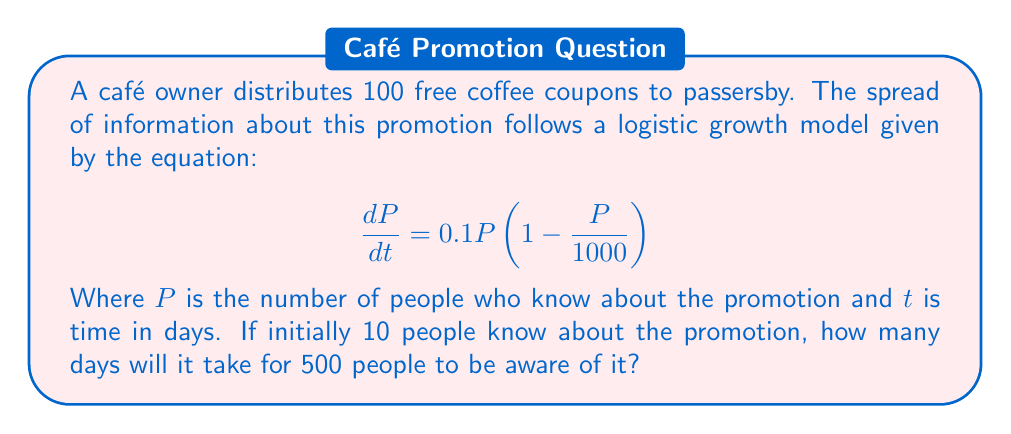Help me with this question. To solve this problem, we need to use the logistic growth model and integrate it to find the time $t$ when $P = 500$. Let's follow these steps:

1) The logistic growth model is given by:
   $$\frac{dP}{dt} = 0.1P(1 - \frac{P}{1000})$$

2) The solution to this differential equation is:
   $$P(t) = \frac{1000}{1 + (\frac{1000}{P_0} - 1)e^{-0.1t}}$$
   Where $P_0$ is the initial population.

3) We're given that $P_0 = 10$ and we want to find $t$ when $P = 500$. Let's substitute these values:
   $$500 = \frac{1000}{1 + (\frac{1000}{10} - 1)e^{-0.1t}}$$

4) Simplify:
   $$500 = \frac{1000}{1 + 99e^{-0.1t}}$$

5) Multiply both sides by $(1 + 99e^{-0.1t})$:
   $$500(1 + 99e^{-0.1t}) = 1000$$

6) Expand:
   $$500 + 49500e^{-0.1t} = 1000$$

7) Subtract 500 from both sides:
   $$49500e^{-0.1t} = 500$$

8) Divide both sides by 49500:
   $$e^{-0.1t} = \frac{1}{99}$$

9) Take the natural log of both sides:
   $$-0.1t = \ln(\frac{1}{99})$$

10) Solve for $t$:
    $$t = -10\ln(\frac{1}{99}) \approx 45.96$$

Therefore, it will take approximately 46 days for 500 people to know about the promotion.
Answer: 46 days 